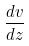<formula> <loc_0><loc_0><loc_500><loc_500>\frac { d v } { d z }</formula> 